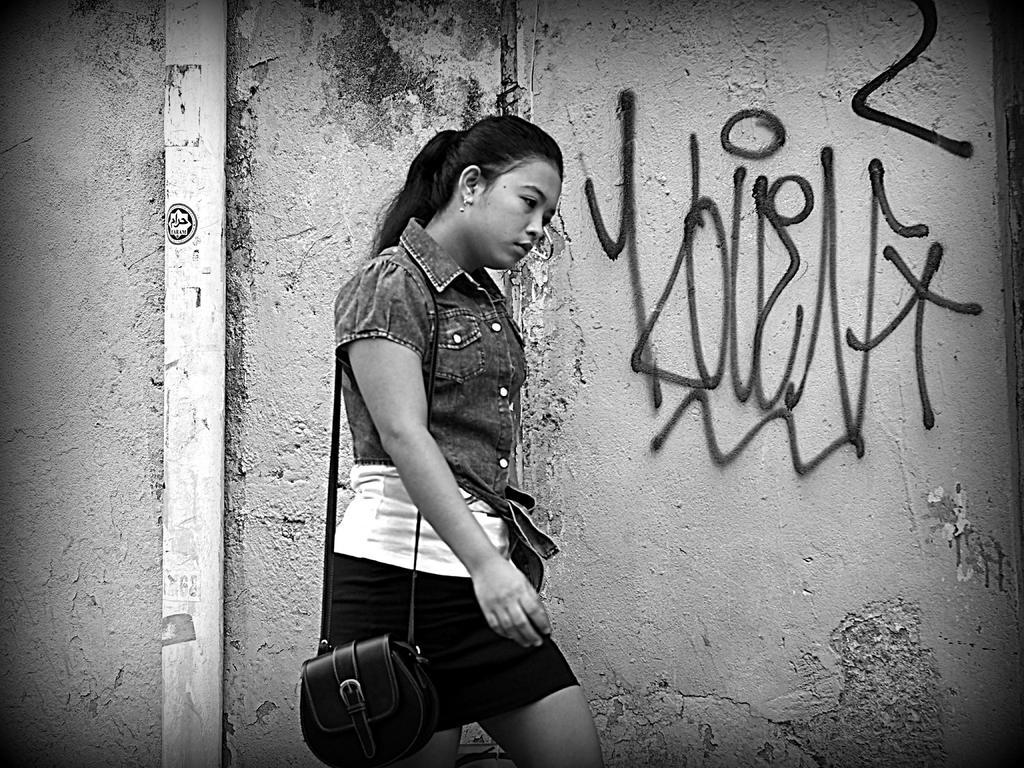Describe this image in one or two sentences. This is a black and white image. We can see a person carrying a bag is standing. In the background, we can see the wall with some text and an object. 